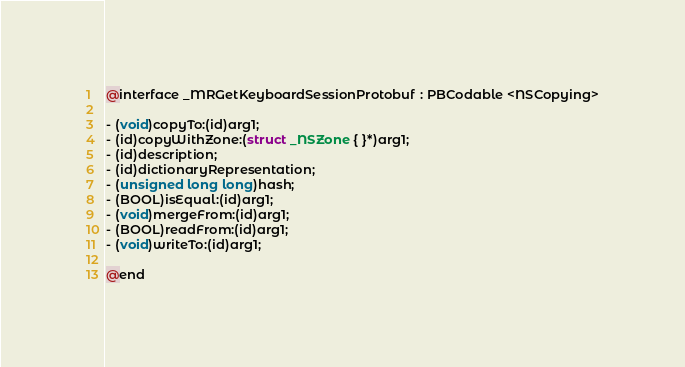<code> <loc_0><loc_0><loc_500><loc_500><_C_>@interface _MRGetKeyboardSessionProtobuf : PBCodable <NSCopying>

- (void)copyTo:(id)arg1;
- (id)copyWithZone:(struct _NSZone { }*)arg1;
- (id)description;
- (id)dictionaryRepresentation;
- (unsigned long long)hash;
- (BOOL)isEqual:(id)arg1;
- (void)mergeFrom:(id)arg1;
- (BOOL)readFrom:(id)arg1;
- (void)writeTo:(id)arg1;

@end
</code> 